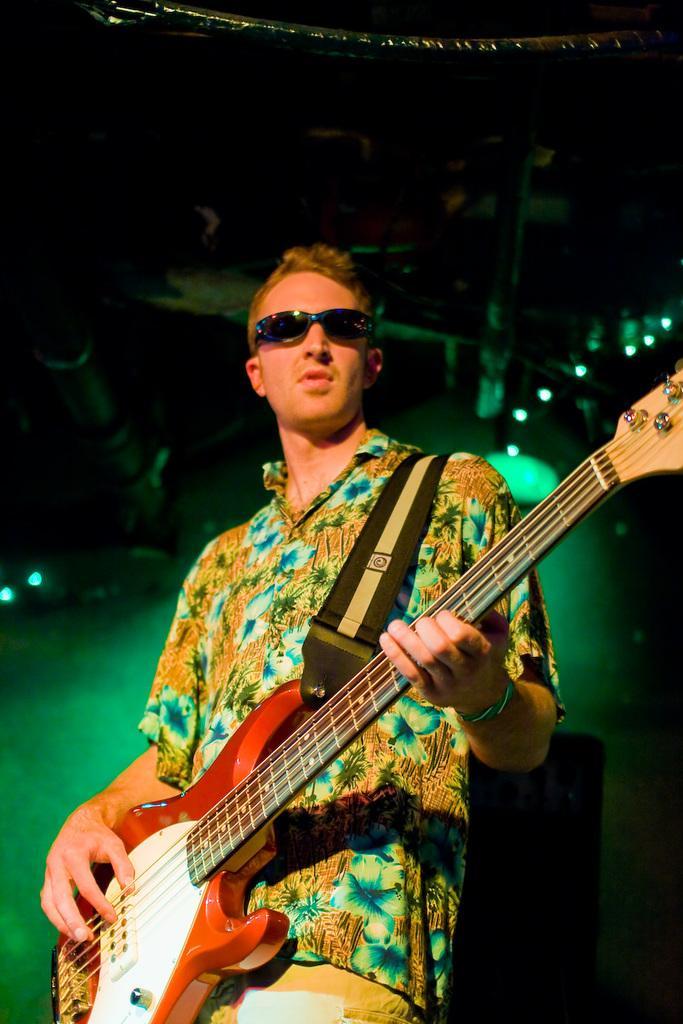Can you describe this image briefly? This person standing and playing guitar and wear glasses. On the top we can see lights. 